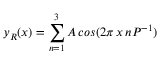<formula> <loc_0><loc_0><loc_500><loc_500>y _ { R } ( x ) = \sum _ { n = 1 } ^ { 3 } A \, \cos ( 2 \pi \, x \, n P ^ { - 1 } )</formula> 